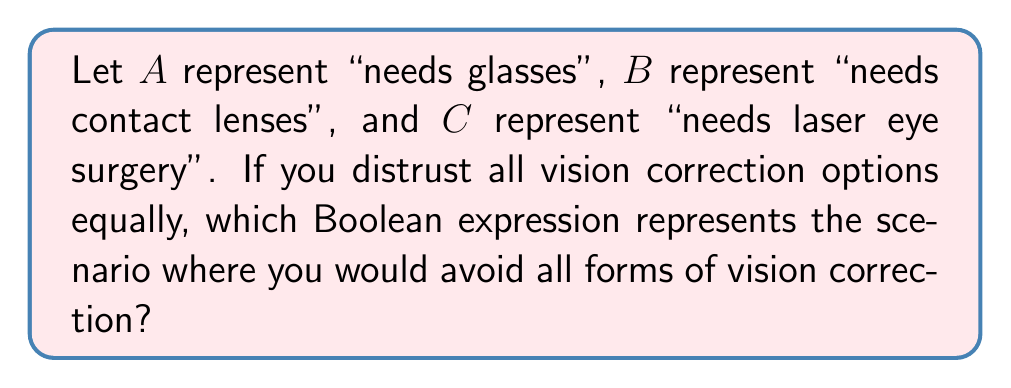Show me your answer to this math problem. To solve this problem, we need to consider the Boolean logic that represents avoiding all forms of vision correction. Let's break it down step-by-step:

1. Not needing glasses is represented by $\overline{A}$
2. Not needing contact lenses is represented by $\overline{B}$
3. Not needing laser eye surgery is represented by $\overline{C}$

To avoid all forms of vision correction, we need to combine these negations using the AND operator. In Boolean algebra, the AND operator is represented by multiplication or the $\wedge$ symbol.

Therefore, the expression to avoid all forms of vision correction is:

$$\overline{A} \wedge \overline{B} \wedge \overline{C}$$

This can also be written as:

$$\overline{A} \cdot \overline{B} \cdot \overline{C}$$

Using De Morgan's law, this expression is equivalent to the negation of the OR of all options:

$$\overline{(A \vee B \vee C)}$$

This last form directly represents "not needing any form of vision correction".
Answer: $\overline{A} \wedge \overline{B} \wedge \overline{C}$ 